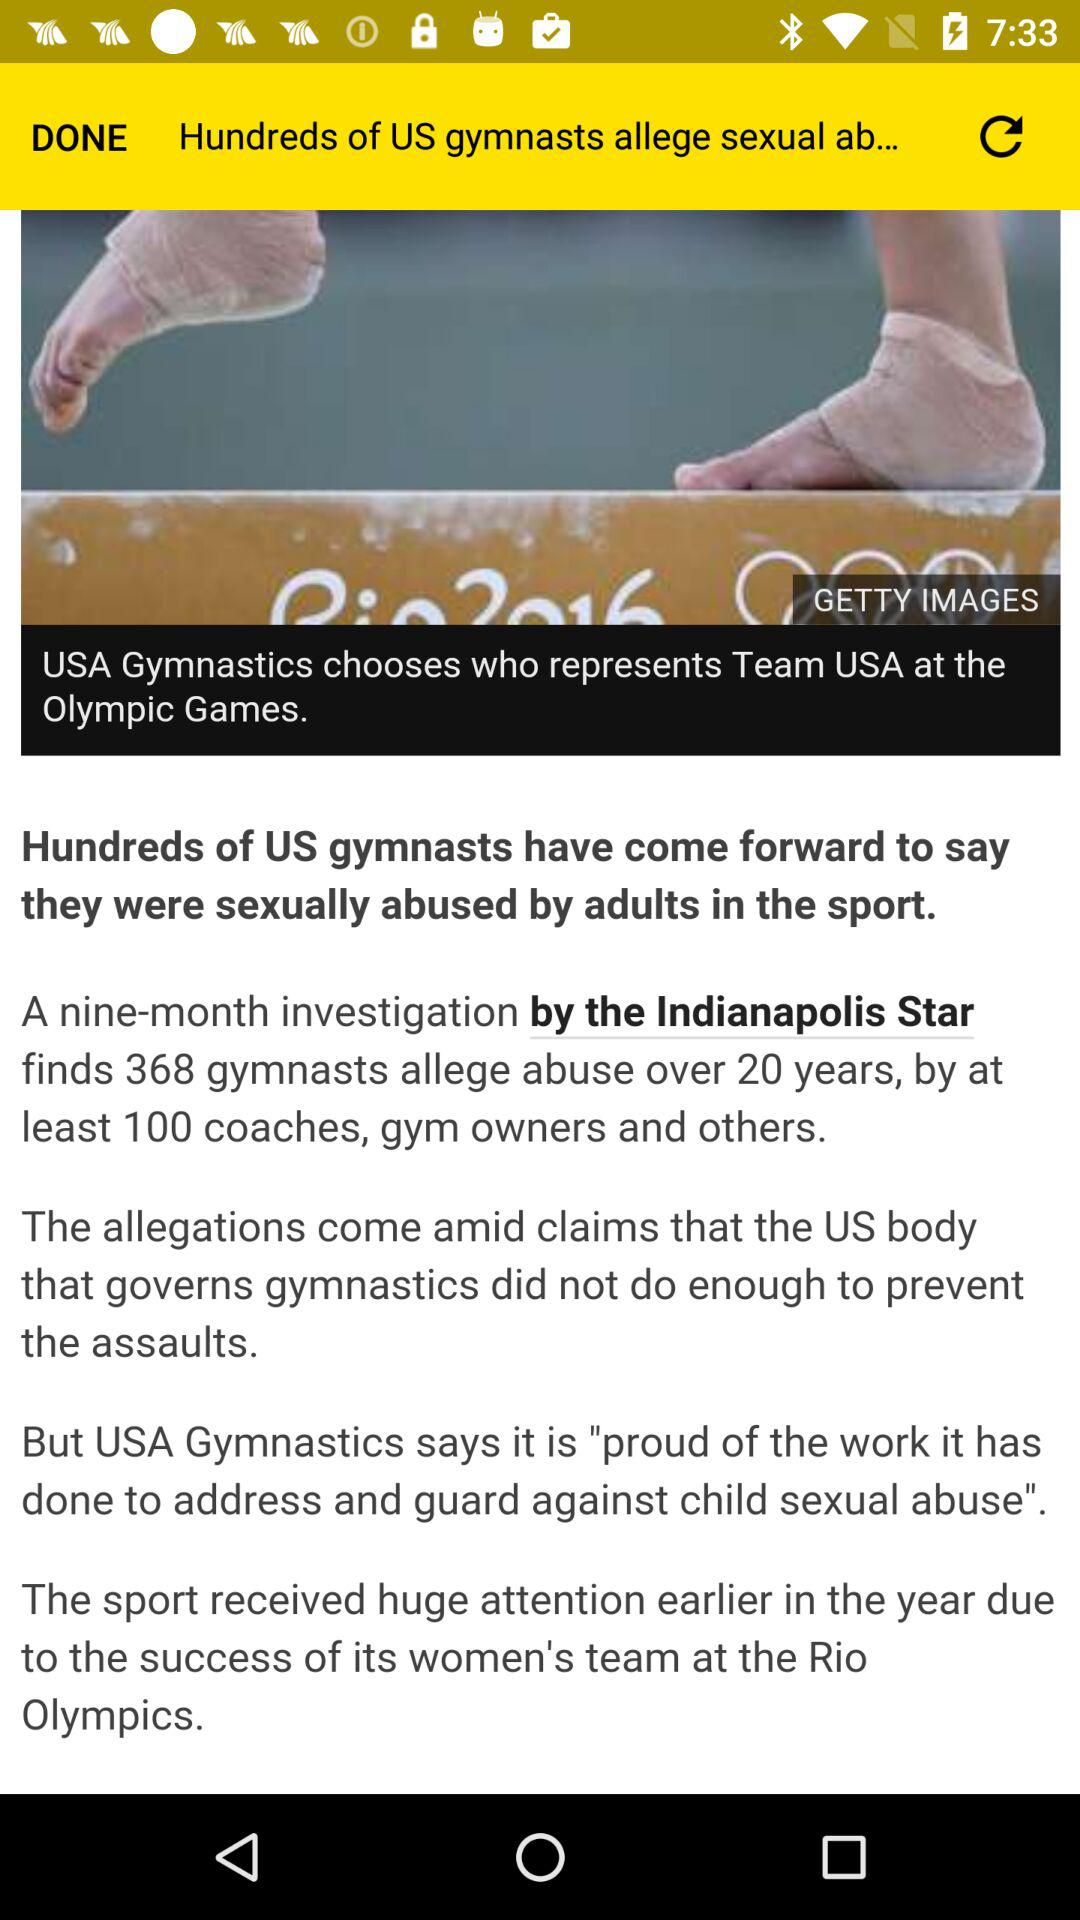Which USA team is represented in the Olympic games?
When the provided information is insufficient, respond with <no answer>. <no answer> 